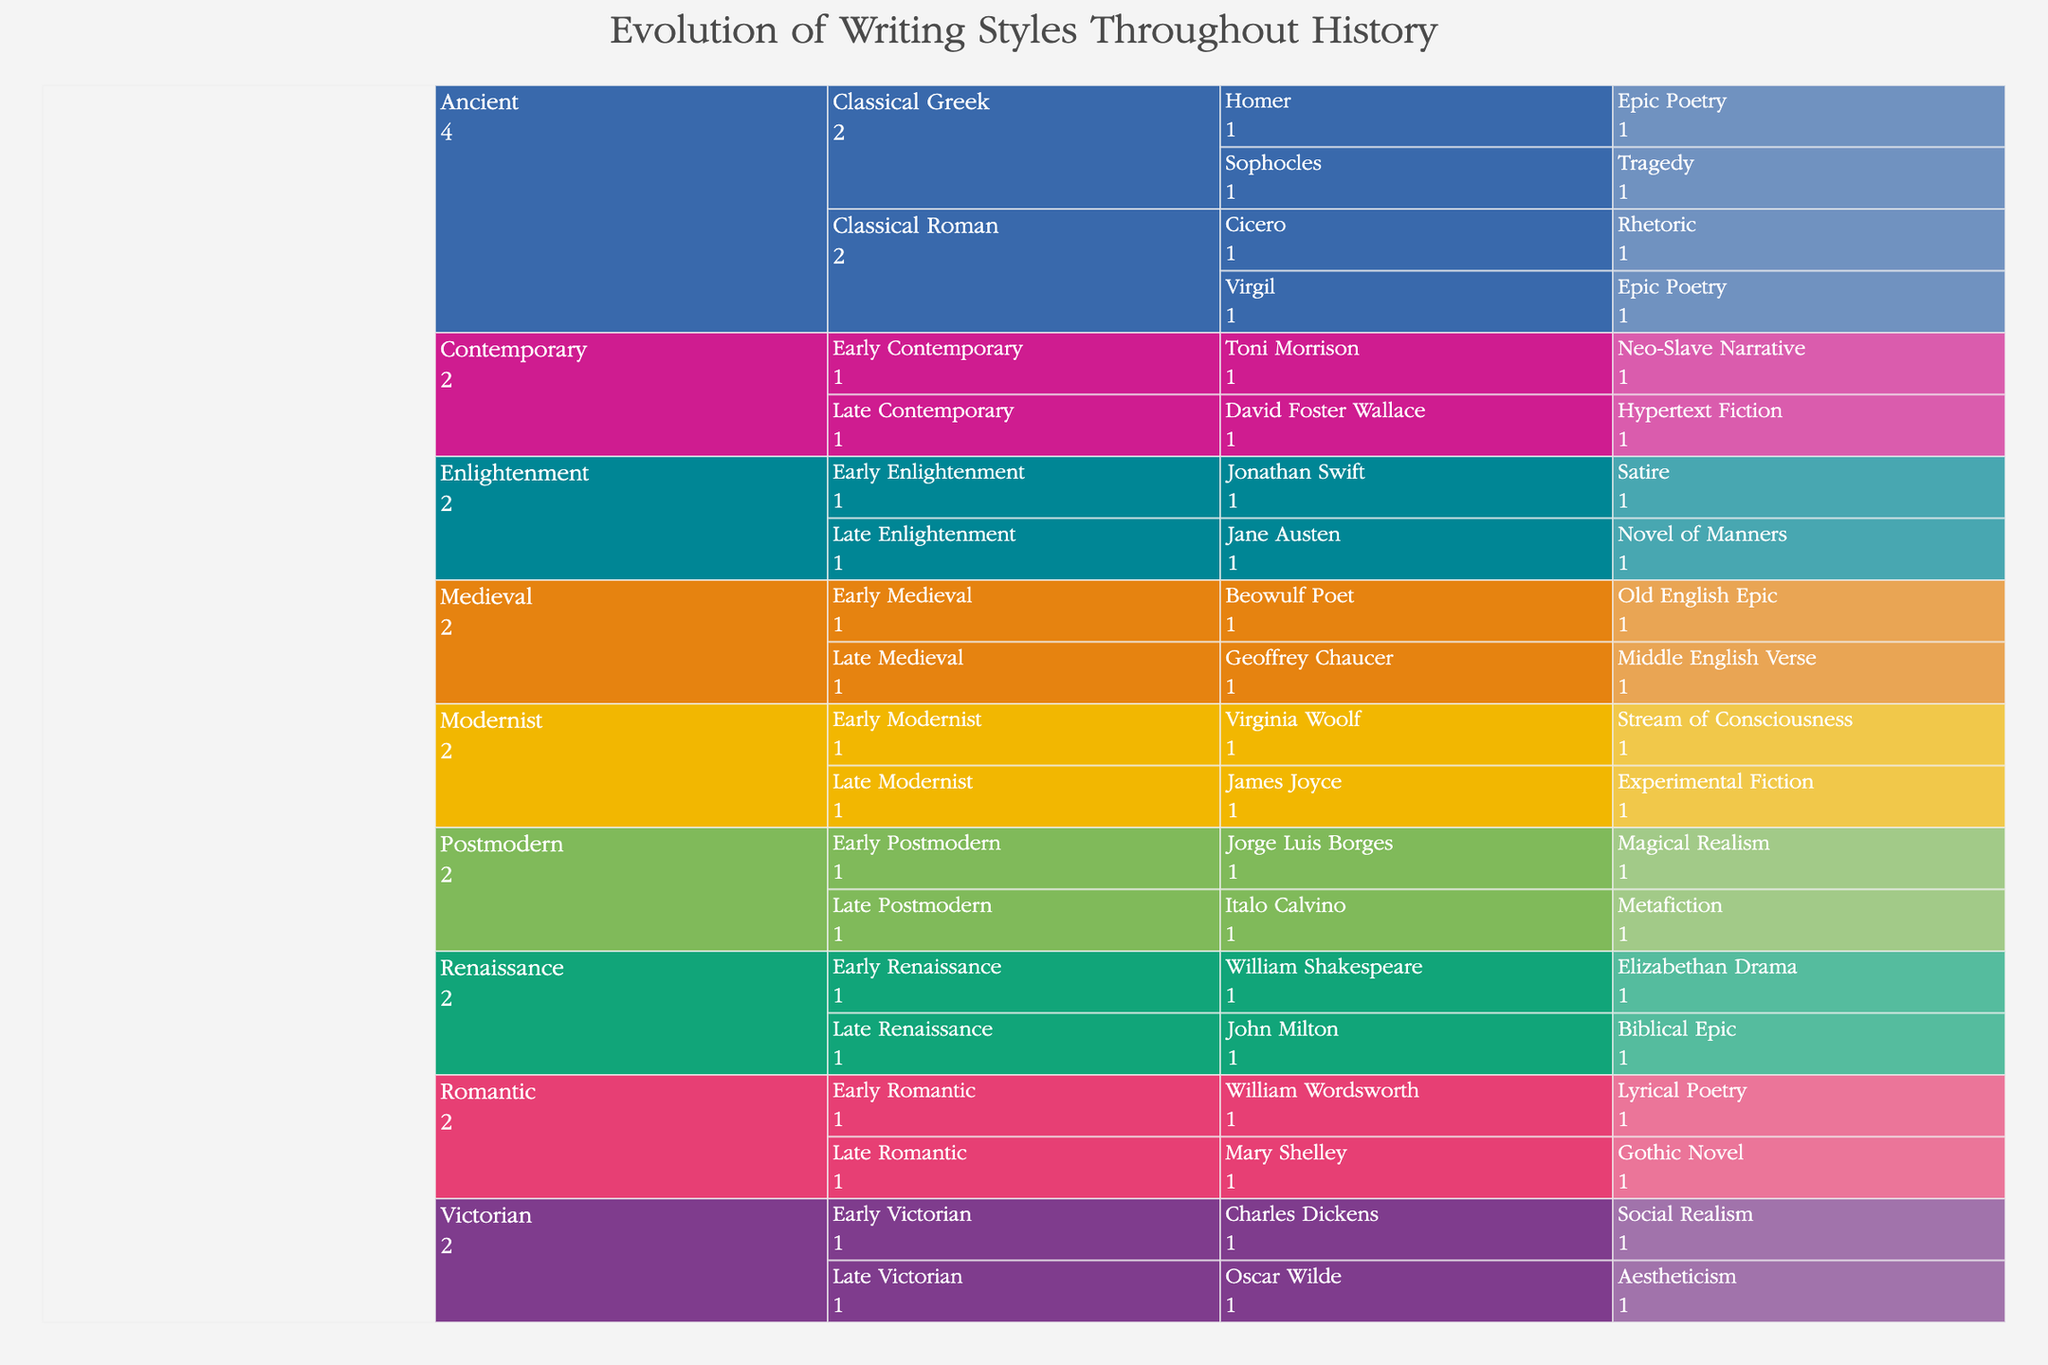Who is classified under "Stream of Consciousness" style? To find the Author using the "Stream of Consciousness" style, start by looking under the Modernist era, particularly within the Early Modernist period. Here, you will see Virginia Woolf listed under that style.
Answer: Virginia Woolf Which period in the Victorian era features an author known for Aestheticism? To determine the period featuring an author known for Aestheticism under the Victorian era, look at both the Early Victorian and Late Victorian periods. You will find that Oscar Wilde is listed under the Late Victorian period with the style Aestheticism.
Answer: Late Victorian How many authors are listed under the Ancient era? To find the number of authors under the Ancient era, look at the Classical Greek and Classical Roman periods and count the authors: Homer, Sophocles, Virgil, and Cicero.
Answer: Four What style is attributed to Mary Shelley? To find the style attributed to Mary Shelley, look under the Romantic era, specifically the Late Romantic period. There you will see Mary Shelley listed with the style Gothic Novel.
Answer: Gothic Novel Which era has the smallest number of styles listed and how many are there? To identify the era with the smallest number of styles, count the distinct styles in each era in the data: Ancient (Epic Poetry, Tragedy, Rhetoric), Medieval (Old English Epic, Middle English Verse), Renaissance (Elizabethan Drama, Biblical Epic), Enlightenment (Satire, Novel of Manners), Romantic (Lyrical Poetry, Gothic Novel), Victorian (Social Realism, Aestheticism), Modernist (Stream of Consciousness, Experimental Fiction), Postmodern (Magical Realism, Metafiction), Contemporary (Neo-Slave Narrative, Hypertext Fiction). Notice that each era typically has two styles, thus none can be said to have fewer based on this data.
Answer: Tied, each has 2 Which author in the Gothic Novel style belongs to the Romantic era? To find the author in the Gothic Novel style belonging to the Romantic era, look under the Romantic era in the Late Romantic period. You will find Mary Shelley listed with the Gothic Novel style.
Answer: Mary Shelley Compare the number of unique styles between Enlightenment and Contemporary eras. Which has more? To compare, count the unique styles in each era: Enlightenment has Satire and Novel of Manners (2 styles), and Contemporary has Neo-Slave Narrative and Hypertext Fiction (2 styles). Both eras have the same number of unique styles.
Answer: Neither, same number 